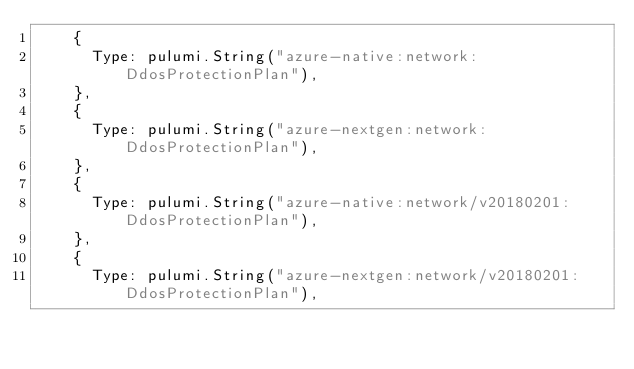Convert code to text. <code><loc_0><loc_0><loc_500><loc_500><_Go_>		{
			Type: pulumi.String("azure-native:network:DdosProtectionPlan"),
		},
		{
			Type: pulumi.String("azure-nextgen:network:DdosProtectionPlan"),
		},
		{
			Type: pulumi.String("azure-native:network/v20180201:DdosProtectionPlan"),
		},
		{
			Type: pulumi.String("azure-nextgen:network/v20180201:DdosProtectionPlan"),</code> 